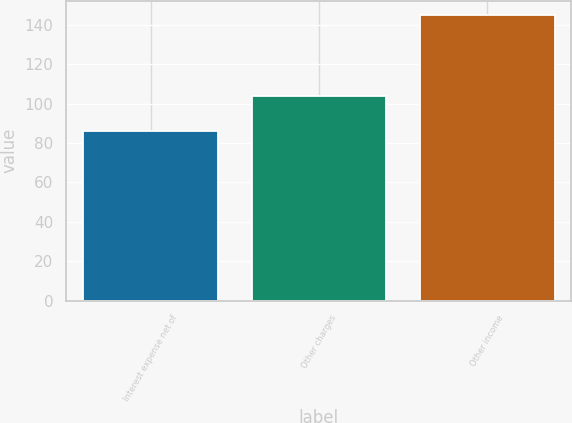Convert chart. <chart><loc_0><loc_0><loc_500><loc_500><bar_chart><fcel>Interest expense net of<fcel>Other charges<fcel>Other income<nl><fcel>86<fcel>104<fcel>145<nl></chart> 